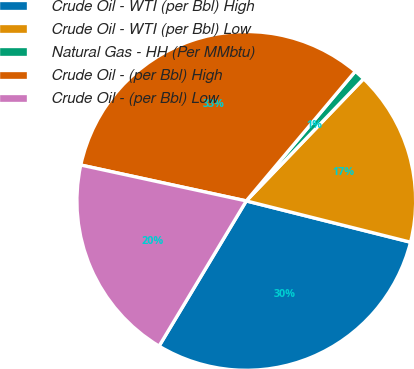Convert chart to OTSL. <chart><loc_0><loc_0><loc_500><loc_500><pie_chart><fcel>Crude Oil - WTI (per Bbl) High<fcel>Crude Oil - WTI (per Bbl) Low<fcel>Natural Gas - HH (Per MMbtu)<fcel>Crude Oil - (per Bbl) High<fcel>Crude Oil - (per Bbl) Low<nl><fcel>29.69%<fcel>16.74%<fcel>1.05%<fcel>32.73%<fcel>19.79%<nl></chart> 